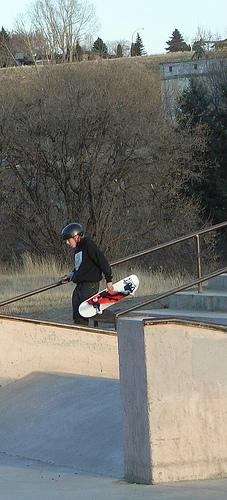Question: what is the man carrying?
Choices:
A. Skateboard.
B. Surf board.
C. Snow board.
D. Wake board.
Answer with the letter. Answer: A Question: what is the man wearing?
Choices:
A. Clothes.
B. Shorts.
C. Shoes.
D. T Shirt.
Answer with the letter. Answer: A 